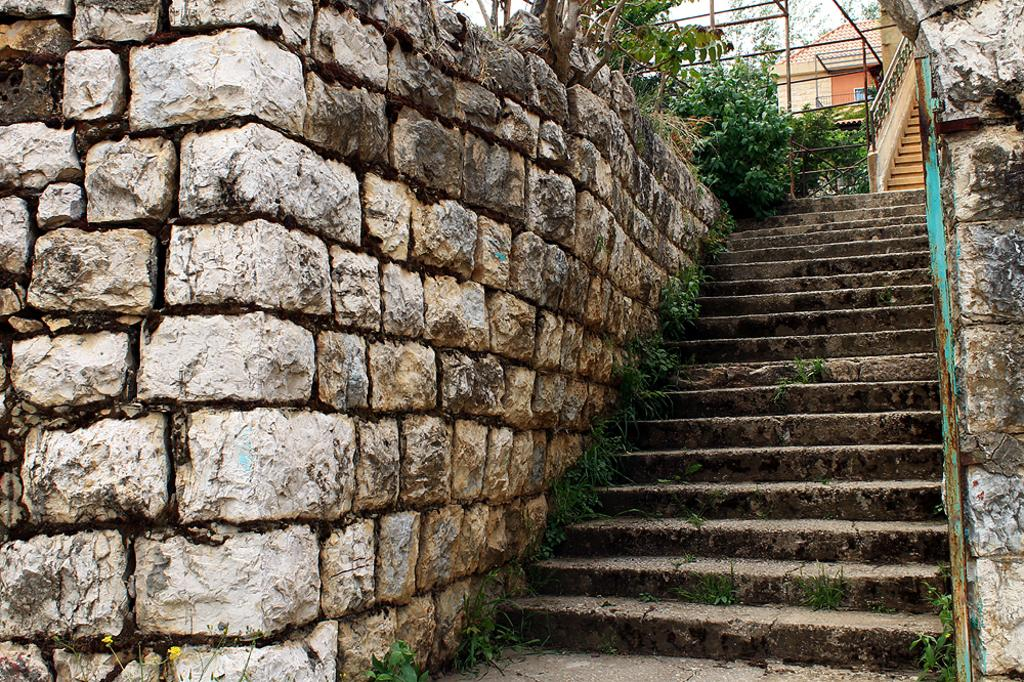What type of structure can be seen in the image? There is a house in the image. What type of terrain is visible in the image? There is grass in the image. What architectural feature is present in the image? There are steps in the image. What type of barrier is present in the image? There is a railing in the image. What type of vertical supports are present in the image? There are poles in the image. What type of vegetation is visible in the image? There are plants and trees in the image. What part of the natural environment is visible in the image? The sky is visible in the image. Who is the manager of the show taking place in the image? There is no show or manager present in the image. What type of fuel is being used by the vehicles in the image? There are no vehicles present in the image. 